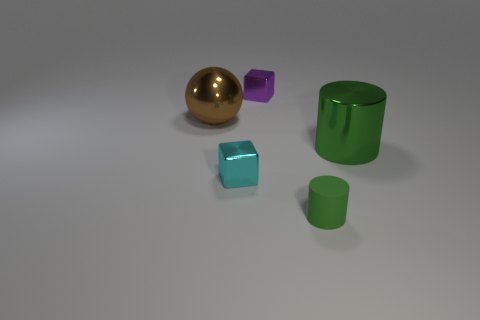What color is the small cube that is the same material as the tiny cyan object?
Keep it short and to the point. Purple. There is a tiny cyan shiny thing; does it have the same shape as the large metallic object to the left of the green matte thing?
Keep it short and to the point. No. Are there any large brown metallic balls on the right side of the big green shiny cylinder?
Your response must be concise. No. There is a tiny object that is the same color as the large cylinder; what is it made of?
Provide a short and direct response. Rubber. Do the brown ball and the cube in front of the big brown sphere have the same size?
Make the answer very short. No. Are there any small cubes that have the same color as the tiny matte thing?
Your response must be concise. No. Is there another large object of the same shape as the big green shiny thing?
Ensure brevity in your answer.  No. There is a metallic thing that is both on the left side of the green metal object and in front of the big brown metallic ball; what is its shape?
Make the answer very short. Cube. How many small cyan cubes are the same material as the tiny purple cube?
Make the answer very short. 1. Is the number of tiny purple shiny cubes to the right of the tiny rubber object less than the number of large purple things?
Your response must be concise. No. 